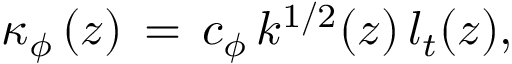Convert formula to latex. <formula><loc_0><loc_0><loc_500><loc_500>\kappa _ { \phi } \left ( z \right ) \, = \, c _ { \phi } \, k ^ { 1 / 2 } ( z ) \, l _ { t } ( z ) ,</formula> 